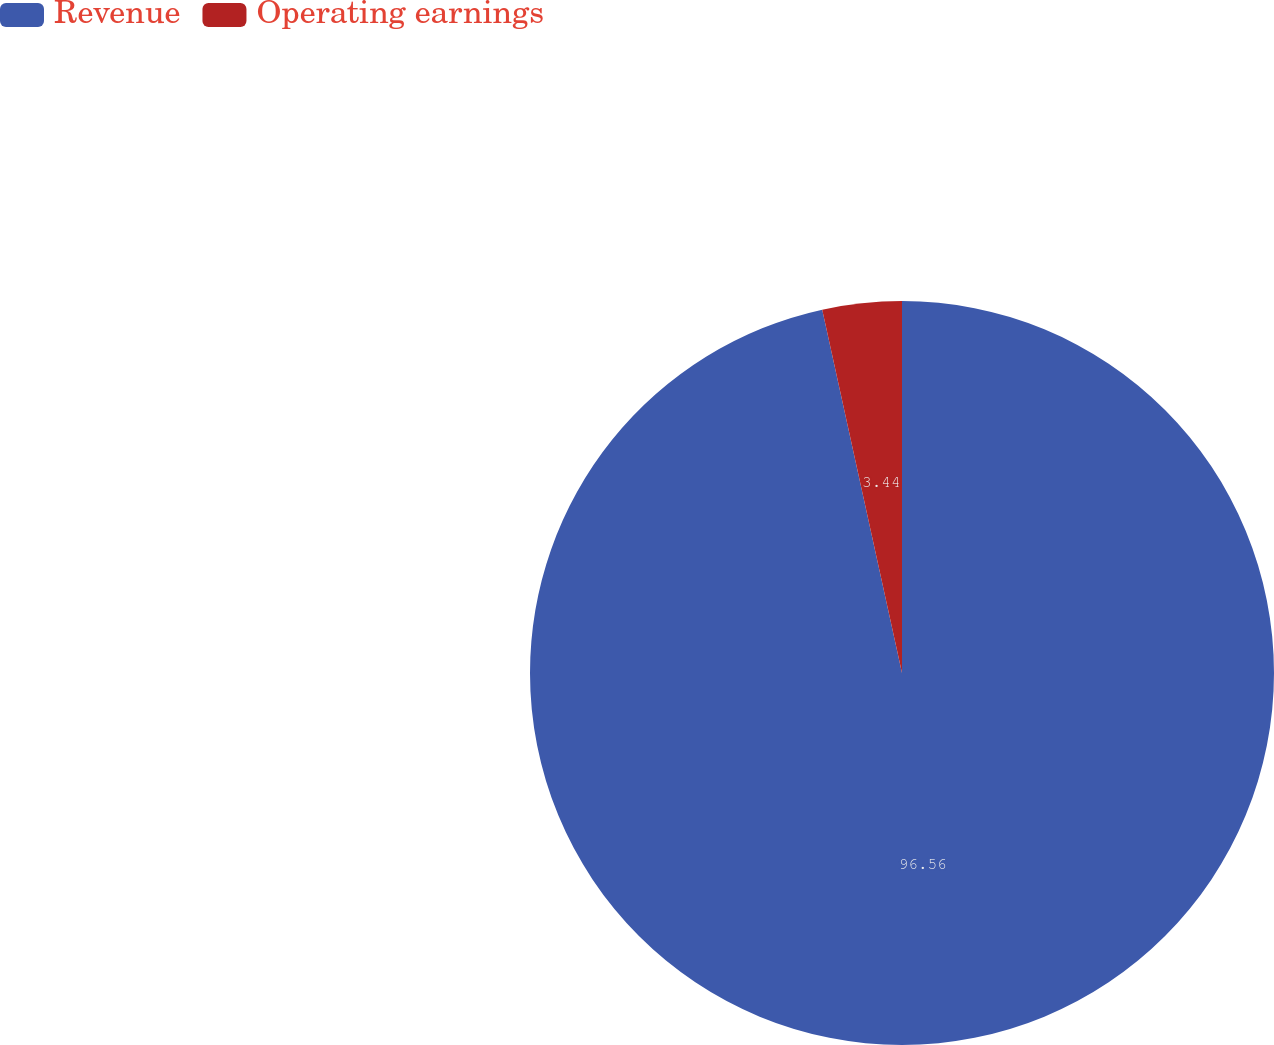<chart> <loc_0><loc_0><loc_500><loc_500><pie_chart><fcel>Revenue<fcel>Operating earnings<nl><fcel>96.56%<fcel>3.44%<nl></chart> 